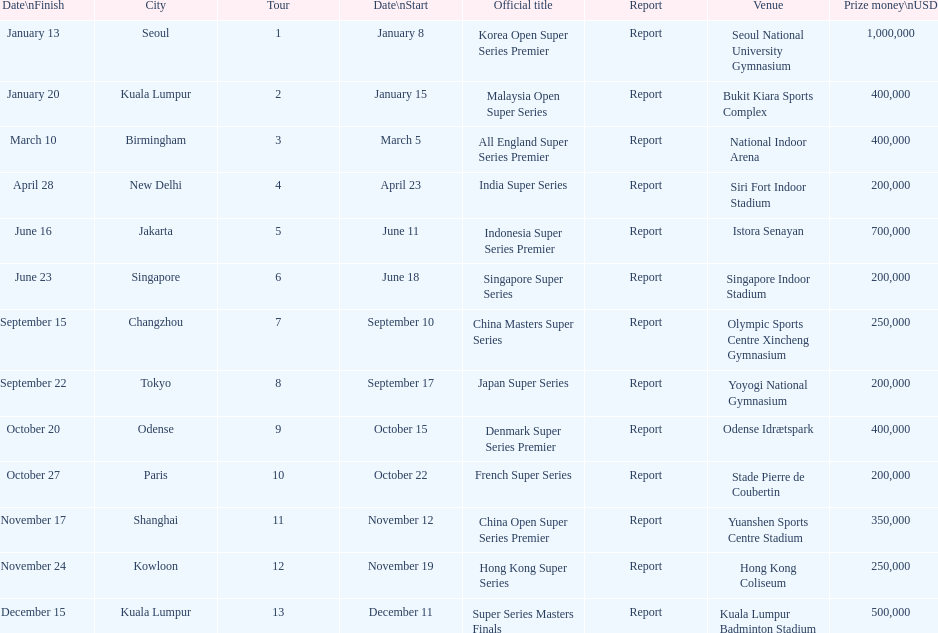Could you parse the entire table? {'header': ['Date\\nFinish', 'City', 'Tour', 'Date\\nStart', 'Official title', 'Report', 'Venue', 'Prize money\\nUSD'], 'rows': [['January 13', 'Seoul', '1', 'January 8', 'Korea Open Super Series Premier', 'Report', 'Seoul National University Gymnasium', '1,000,000'], ['January 20', 'Kuala Lumpur', '2', 'January 15', 'Malaysia Open Super Series', 'Report', 'Bukit Kiara Sports Complex', '400,000'], ['March 10', 'Birmingham', '3', 'March 5', 'All England Super Series Premier', 'Report', 'National Indoor Arena', '400,000'], ['April 28', 'New Delhi', '4', 'April 23', 'India Super Series', 'Report', 'Siri Fort Indoor Stadium', '200,000'], ['June 16', 'Jakarta', '5', 'June 11', 'Indonesia Super Series Premier', 'Report', 'Istora Senayan', '700,000'], ['June 23', 'Singapore', '6', 'June 18', 'Singapore Super Series', 'Report', 'Singapore Indoor Stadium', '200,000'], ['September 15', 'Changzhou', '7', 'September 10', 'China Masters Super Series', 'Report', 'Olympic Sports Centre Xincheng Gymnasium', '250,000'], ['September 22', 'Tokyo', '8', 'September 17', 'Japan Super Series', 'Report', 'Yoyogi National Gymnasium', '200,000'], ['October 20', 'Odense', '9', 'October 15', 'Denmark Super Series Premier', 'Report', 'Odense Idrætspark', '400,000'], ['October 27', 'Paris', '10', 'October 22', 'French Super Series', 'Report', 'Stade Pierre de Coubertin', '200,000'], ['November 17', 'Shanghai', '11', 'November 12', 'China Open Super Series Premier', 'Report', 'Yuanshen Sports Centre Stadium', '350,000'], ['November 24', 'Kowloon', '12', 'November 19', 'Hong Kong Super Series', 'Report', 'Hong Kong Coliseum', '250,000'], ['December 15', 'Kuala Lumpur', '13', 'December 11', 'Super Series Masters Finals', 'Report', 'Kuala Lumpur Badminton Stadium', '500,000']]} Does the malaysia open super series pay more or less than french super series? More. 